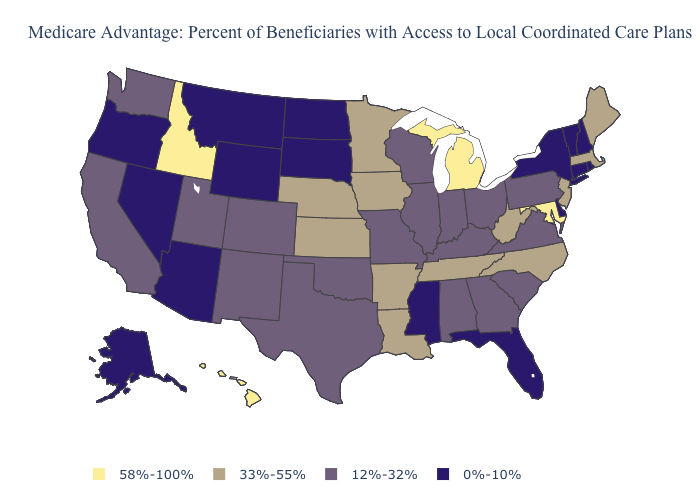What is the highest value in the South ?
Answer briefly. 58%-100%. What is the value of Kansas?
Concise answer only. 33%-55%. What is the value of Michigan?
Short answer required. 58%-100%. Does the map have missing data?
Keep it brief. No. Among the states that border New York , does Massachusetts have the lowest value?
Give a very brief answer. No. What is the value of Delaware?
Concise answer only. 0%-10%. Which states have the lowest value in the USA?
Keep it brief. Alaska, Arizona, Connecticut, Delaware, Florida, Mississippi, Montana, North Dakota, New Hampshire, Nevada, New York, Oregon, Rhode Island, South Dakota, Vermont, Wyoming. Name the states that have a value in the range 12%-32%?
Be succinct. Alabama, California, Colorado, Georgia, Illinois, Indiana, Kentucky, Missouri, New Mexico, Ohio, Oklahoma, Pennsylvania, South Carolina, Texas, Utah, Virginia, Washington, Wisconsin. What is the highest value in the MidWest ?
Quick response, please. 58%-100%. Among the states that border Indiana , does Michigan have the highest value?
Concise answer only. Yes. Name the states that have a value in the range 33%-55%?
Answer briefly. Arkansas, Iowa, Kansas, Louisiana, Massachusetts, Maine, Minnesota, North Carolina, Nebraska, New Jersey, Tennessee, West Virginia. Which states have the lowest value in the MidWest?
Short answer required. North Dakota, South Dakota. Which states have the lowest value in the South?
Quick response, please. Delaware, Florida, Mississippi. Does Idaho have the highest value in the West?
Short answer required. Yes. Name the states that have a value in the range 0%-10%?
Short answer required. Alaska, Arizona, Connecticut, Delaware, Florida, Mississippi, Montana, North Dakota, New Hampshire, Nevada, New York, Oregon, Rhode Island, South Dakota, Vermont, Wyoming. 